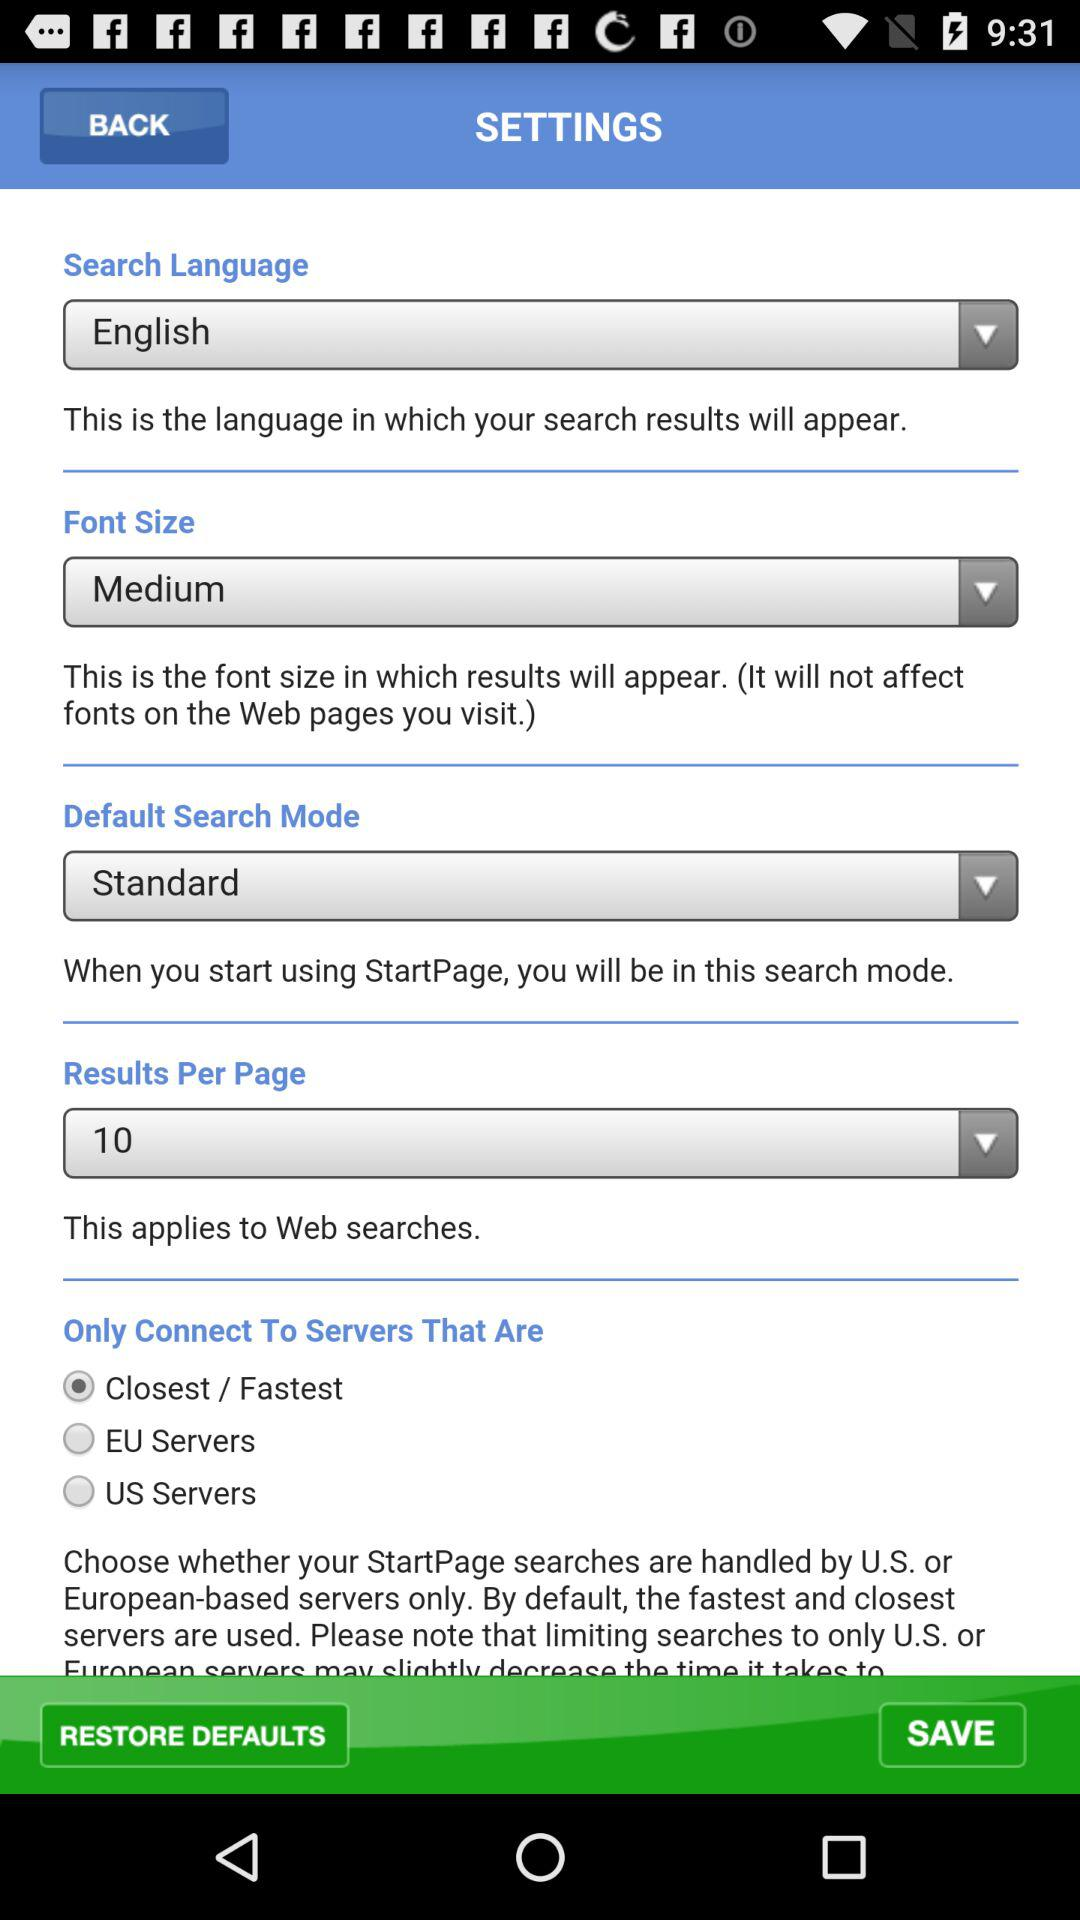What is the default search mode? The default search mode is "Standard". 